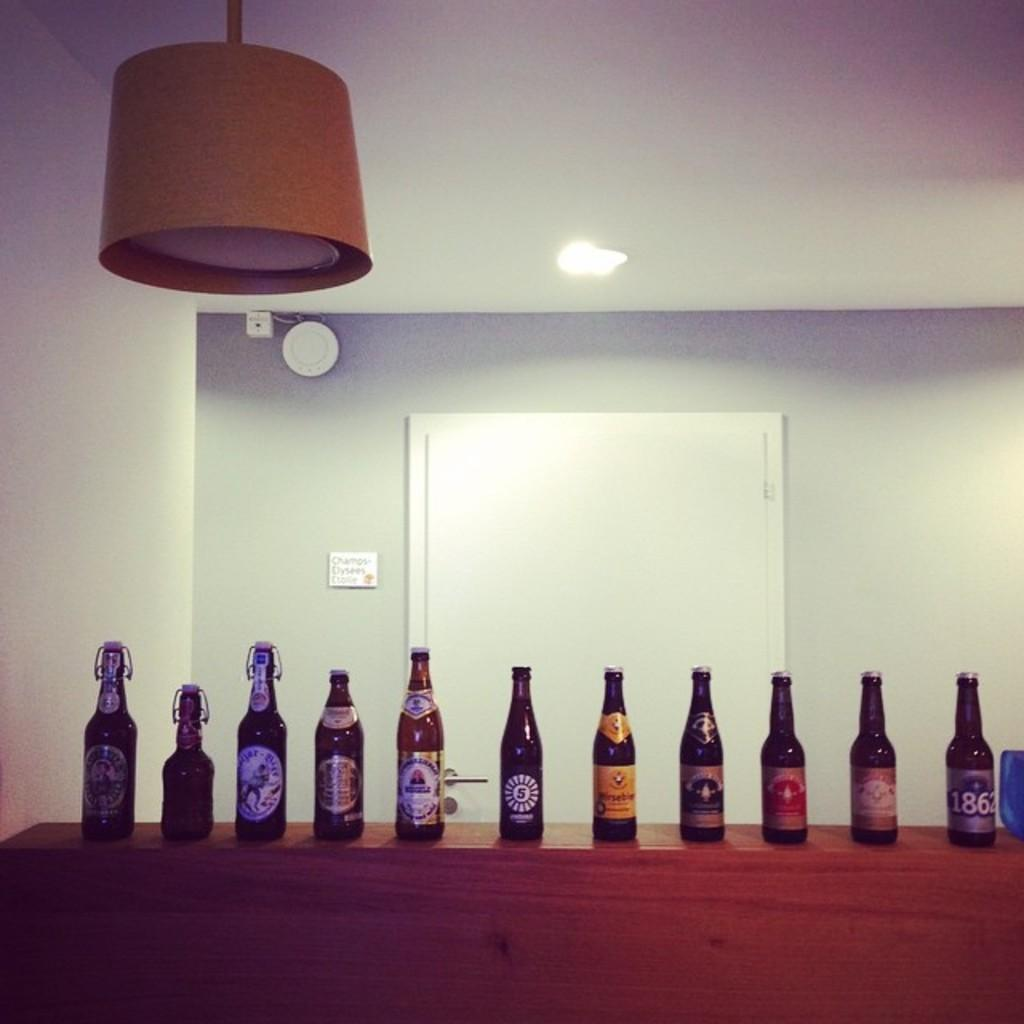<image>
Give a short and clear explanation of the subsequent image. Beer bottles are lined on a counter including one with 1862 on the label. 